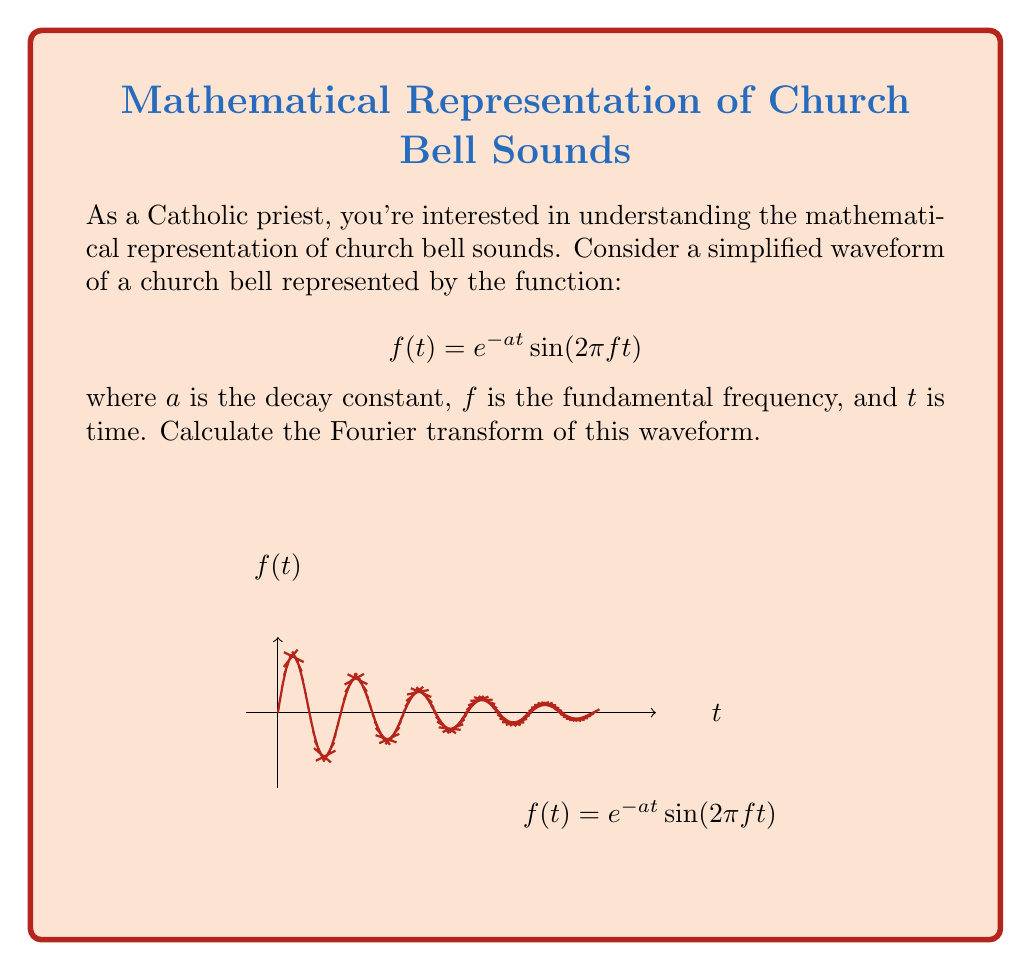What is the answer to this math problem? To calculate the Fourier transform of the given waveform, we'll follow these steps:

1) The Fourier transform is defined as:
   $$F(\omega) = \int_{-\infty}^{\infty} f(t) e^{-i\omega t} dt$$

2) Substituting our function:
   $$F(\omega) = \int_{-\infty}^{\infty} e^{-at}\sin(2\pi ft) e^{-i\omega t} dt$$

3) Using Euler's formula, we can rewrite sin:
   $$\sin(2\pi ft) = \frac{e^{i2\pi ft} - e^{-i2\pi ft}}{2i}$$

4) Substituting this back:
   $$F(\omega) = \frac{1}{2i}\int_{-\infty}^{\infty} e^{-at}(e^{i2\pi ft} - e^{-i2\pi ft}) e^{-i\omega t} dt$$

5) Simplifying:
   $$F(\omega) = \frac{1}{2i}\int_{-\infty}^{\infty} (e^{-(a+i\omega-i2\pi f)t} - e^{-(a+i\omega+i2\pi f)t}) dt$$

6) Integrating:
   $$F(\omega) = \frac{1}{2i}\left[\frac{1}{a+i\omega-i2\pi f} - \frac{1}{a+i\omega+i2\pi f}\right]$$

7) Finding a common denominator:
   $$F(\omega) = \frac{1}{2i}\frac{(a+i\omega+i2\pi f) - (a+i\omega-i2\pi f)}{(a+i\omega)^2 + (2\pi f)^2}$$

8) Simplifying:
   $$F(\omega) = \frac{2\pi f}{(a+i\omega)^2 + (2\pi f)^2}$$

This is the Fourier transform of the church bell waveform.
Answer: $$F(\omega) = \frac{2\pi f}{(a+i\omega)^2 + (2\pi f)^2}$$ 